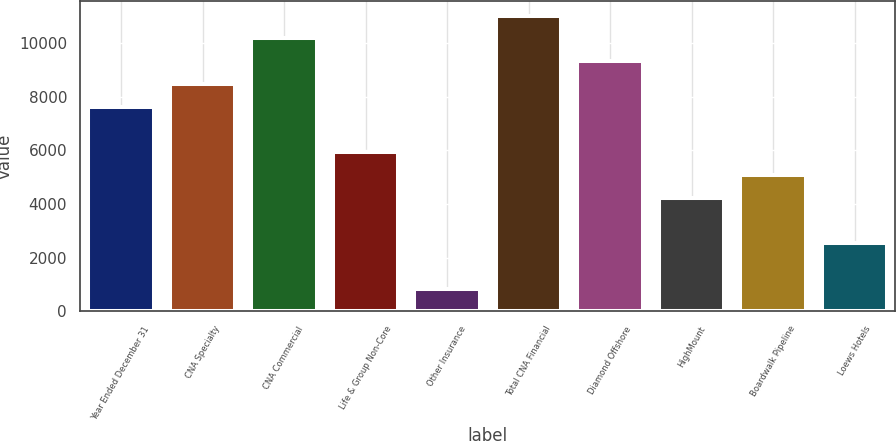Convert chart to OTSL. <chart><loc_0><loc_0><loc_500><loc_500><bar_chart><fcel>Year Ended December 31<fcel>CNA Specialty<fcel>CNA Commercial<fcel>Life & Group Non-Core<fcel>Other Insurance<fcel>Total CNA Financial<fcel>Diamond Offshore<fcel>HighMount<fcel>Boardwalk Pipeline<fcel>Loews Hotels<nl><fcel>7625<fcel>8472<fcel>10166<fcel>5931<fcel>849<fcel>11013<fcel>9319<fcel>4237<fcel>5084<fcel>2543<nl></chart> 